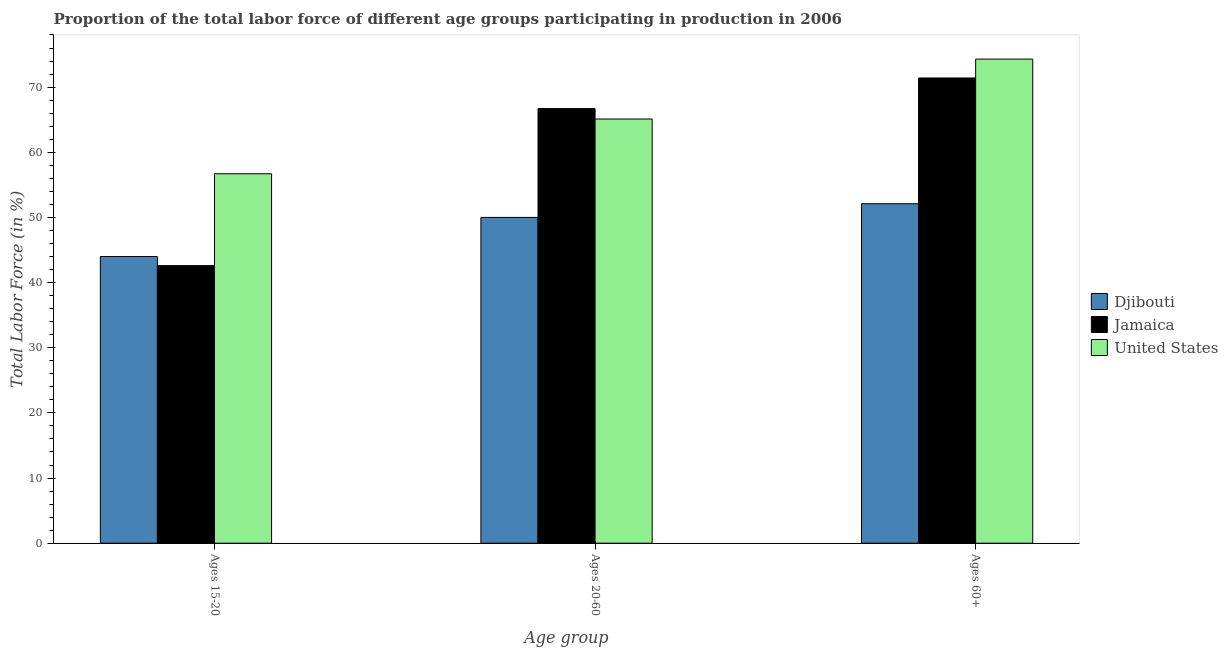How many groups of bars are there?
Provide a short and direct response. 3. Are the number of bars per tick equal to the number of legend labels?
Your response must be concise. Yes. What is the label of the 1st group of bars from the left?
Your response must be concise. Ages 15-20. What is the percentage of labor force above age 60 in Jamaica?
Keep it short and to the point. 71.4. Across all countries, what is the maximum percentage of labor force within the age group 15-20?
Offer a very short reply. 56.7. Across all countries, what is the minimum percentage of labor force within the age group 15-20?
Your answer should be compact. 42.6. In which country was the percentage of labor force within the age group 15-20 minimum?
Provide a short and direct response. Jamaica. What is the total percentage of labor force above age 60 in the graph?
Give a very brief answer. 197.8. What is the difference between the percentage of labor force above age 60 in Djibouti and that in United States?
Your answer should be very brief. -22.2. What is the difference between the percentage of labor force within the age group 20-60 in Jamaica and the percentage of labor force above age 60 in Djibouti?
Make the answer very short. 14.6. What is the average percentage of labor force above age 60 per country?
Your response must be concise. 65.93. What is the difference between the percentage of labor force within the age group 15-20 and percentage of labor force above age 60 in Djibouti?
Your response must be concise. -8.1. In how many countries, is the percentage of labor force above age 60 greater than 22 %?
Make the answer very short. 3. What is the ratio of the percentage of labor force above age 60 in Jamaica to that in Djibouti?
Keep it short and to the point. 1.37. What is the difference between the highest and the second highest percentage of labor force within the age group 20-60?
Keep it short and to the point. 1.6. What is the difference between the highest and the lowest percentage of labor force within the age group 20-60?
Offer a very short reply. 16.7. What does the 2nd bar from the left in Ages 20-60 represents?
Give a very brief answer. Jamaica. What does the 2nd bar from the right in Ages 15-20 represents?
Offer a terse response. Jamaica. Is it the case that in every country, the sum of the percentage of labor force within the age group 15-20 and percentage of labor force within the age group 20-60 is greater than the percentage of labor force above age 60?
Offer a terse response. Yes. Are all the bars in the graph horizontal?
Provide a succinct answer. No. How many countries are there in the graph?
Your answer should be compact. 3. What is the difference between two consecutive major ticks on the Y-axis?
Ensure brevity in your answer.  10. Are the values on the major ticks of Y-axis written in scientific E-notation?
Give a very brief answer. No. Does the graph contain any zero values?
Ensure brevity in your answer.  No. How many legend labels are there?
Your answer should be compact. 3. How are the legend labels stacked?
Ensure brevity in your answer.  Vertical. What is the title of the graph?
Your answer should be very brief. Proportion of the total labor force of different age groups participating in production in 2006. What is the label or title of the X-axis?
Give a very brief answer. Age group. What is the Total Labor Force (in %) of Djibouti in Ages 15-20?
Make the answer very short. 44. What is the Total Labor Force (in %) of Jamaica in Ages 15-20?
Offer a terse response. 42.6. What is the Total Labor Force (in %) of United States in Ages 15-20?
Provide a succinct answer. 56.7. What is the Total Labor Force (in %) in Jamaica in Ages 20-60?
Ensure brevity in your answer.  66.7. What is the Total Labor Force (in %) in United States in Ages 20-60?
Ensure brevity in your answer.  65.1. What is the Total Labor Force (in %) of Djibouti in Ages 60+?
Your answer should be compact. 52.1. What is the Total Labor Force (in %) of Jamaica in Ages 60+?
Offer a very short reply. 71.4. What is the Total Labor Force (in %) in United States in Ages 60+?
Provide a short and direct response. 74.3. Across all Age group, what is the maximum Total Labor Force (in %) of Djibouti?
Your answer should be compact. 52.1. Across all Age group, what is the maximum Total Labor Force (in %) of Jamaica?
Your response must be concise. 71.4. Across all Age group, what is the maximum Total Labor Force (in %) in United States?
Your response must be concise. 74.3. Across all Age group, what is the minimum Total Labor Force (in %) of Djibouti?
Your answer should be very brief. 44. Across all Age group, what is the minimum Total Labor Force (in %) in Jamaica?
Your answer should be compact. 42.6. Across all Age group, what is the minimum Total Labor Force (in %) in United States?
Your response must be concise. 56.7. What is the total Total Labor Force (in %) in Djibouti in the graph?
Make the answer very short. 146.1. What is the total Total Labor Force (in %) in Jamaica in the graph?
Offer a very short reply. 180.7. What is the total Total Labor Force (in %) of United States in the graph?
Ensure brevity in your answer.  196.1. What is the difference between the Total Labor Force (in %) of Djibouti in Ages 15-20 and that in Ages 20-60?
Give a very brief answer. -6. What is the difference between the Total Labor Force (in %) of Jamaica in Ages 15-20 and that in Ages 20-60?
Keep it short and to the point. -24.1. What is the difference between the Total Labor Force (in %) in Djibouti in Ages 15-20 and that in Ages 60+?
Keep it short and to the point. -8.1. What is the difference between the Total Labor Force (in %) in Jamaica in Ages 15-20 and that in Ages 60+?
Make the answer very short. -28.8. What is the difference between the Total Labor Force (in %) of United States in Ages 15-20 and that in Ages 60+?
Give a very brief answer. -17.6. What is the difference between the Total Labor Force (in %) of United States in Ages 20-60 and that in Ages 60+?
Your answer should be very brief. -9.2. What is the difference between the Total Labor Force (in %) in Djibouti in Ages 15-20 and the Total Labor Force (in %) in Jamaica in Ages 20-60?
Your answer should be very brief. -22.7. What is the difference between the Total Labor Force (in %) of Djibouti in Ages 15-20 and the Total Labor Force (in %) of United States in Ages 20-60?
Ensure brevity in your answer.  -21.1. What is the difference between the Total Labor Force (in %) of Jamaica in Ages 15-20 and the Total Labor Force (in %) of United States in Ages 20-60?
Your answer should be compact. -22.5. What is the difference between the Total Labor Force (in %) in Djibouti in Ages 15-20 and the Total Labor Force (in %) in Jamaica in Ages 60+?
Provide a succinct answer. -27.4. What is the difference between the Total Labor Force (in %) of Djibouti in Ages 15-20 and the Total Labor Force (in %) of United States in Ages 60+?
Provide a succinct answer. -30.3. What is the difference between the Total Labor Force (in %) in Jamaica in Ages 15-20 and the Total Labor Force (in %) in United States in Ages 60+?
Give a very brief answer. -31.7. What is the difference between the Total Labor Force (in %) of Djibouti in Ages 20-60 and the Total Labor Force (in %) of Jamaica in Ages 60+?
Provide a short and direct response. -21.4. What is the difference between the Total Labor Force (in %) of Djibouti in Ages 20-60 and the Total Labor Force (in %) of United States in Ages 60+?
Provide a short and direct response. -24.3. What is the difference between the Total Labor Force (in %) in Jamaica in Ages 20-60 and the Total Labor Force (in %) in United States in Ages 60+?
Your response must be concise. -7.6. What is the average Total Labor Force (in %) in Djibouti per Age group?
Offer a terse response. 48.7. What is the average Total Labor Force (in %) in Jamaica per Age group?
Keep it short and to the point. 60.23. What is the average Total Labor Force (in %) in United States per Age group?
Provide a succinct answer. 65.37. What is the difference between the Total Labor Force (in %) of Djibouti and Total Labor Force (in %) of Jamaica in Ages 15-20?
Your answer should be compact. 1.4. What is the difference between the Total Labor Force (in %) in Djibouti and Total Labor Force (in %) in United States in Ages 15-20?
Ensure brevity in your answer.  -12.7. What is the difference between the Total Labor Force (in %) of Jamaica and Total Labor Force (in %) of United States in Ages 15-20?
Your response must be concise. -14.1. What is the difference between the Total Labor Force (in %) in Djibouti and Total Labor Force (in %) in Jamaica in Ages 20-60?
Provide a short and direct response. -16.7. What is the difference between the Total Labor Force (in %) in Djibouti and Total Labor Force (in %) in United States in Ages 20-60?
Offer a terse response. -15.1. What is the difference between the Total Labor Force (in %) in Djibouti and Total Labor Force (in %) in Jamaica in Ages 60+?
Your answer should be compact. -19.3. What is the difference between the Total Labor Force (in %) in Djibouti and Total Labor Force (in %) in United States in Ages 60+?
Offer a very short reply. -22.2. What is the difference between the Total Labor Force (in %) in Jamaica and Total Labor Force (in %) in United States in Ages 60+?
Ensure brevity in your answer.  -2.9. What is the ratio of the Total Labor Force (in %) of Jamaica in Ages 15-20 to that in Ages 20-60?
Your answer should be compact. 0.64. What is the ratio of the Total Labor Force (in %) in United States in Ages 15-20 to that in Ages 20-60?
Give a very brief answer. 0.87. What is the ratio of the Total Labor Force (in %) in Djibouti in Ages 15-20 to that in Ages 60+?
Offer a terse response. 0.84. What is the ratio of the Total Labor Force (in %) of Jamaica in Ages 15-20 to that in Ages 60+?
Make the answer very short. 0.6. What is the ratio of the Total Labor Force (in %) in United States in Ages 15-20 to that in Ages 60+?
Keep it short and to the point. 0.76. What is the ratio of the Total Labor Force (in %) in Djibouti in Ages 20-60 to that in Ages 60+?
Make the answer very short. 0.96. What is the ratio of the Total Labor Force (in %) in Jamaica in Ages 20-60 to that in Ages 60+?
Make the answer very short. 0.93. What is the ratio of the Total Labor Force (in %) of United States in Ages 20-60 to that in Ages 60+?
Ensure brevity in your answer.  0.88. What is the difference between the highest and the second highest Total Labor Force (in %) of Djibouti?
Your answer should be very brief. 2.1. What is the difference between the highest and the second highest Total Labor Force (in %) of United States?
Ensure brevity in your answer.  9.2. What is the difference between the highest and the lowest Total Labor Force (in %) in Jamaica?
Keep it short and to the point. 28.8. 